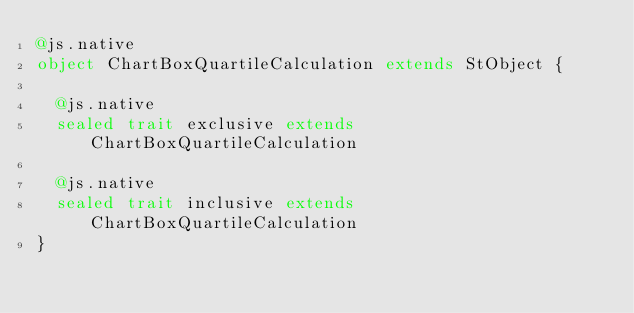<code> <loc_0><loc_0><loc_500><loc_500><_Scala_>@js.native
object ChartBoxQuartileCalculation extends StObject {
  
  @js.native
  sealed trait exclusive extends ChartBoxQuartileCalculation
  
  @js.native
  sealed trait inclusive extends ChartBoxQuartileCalculation
}
</code> 